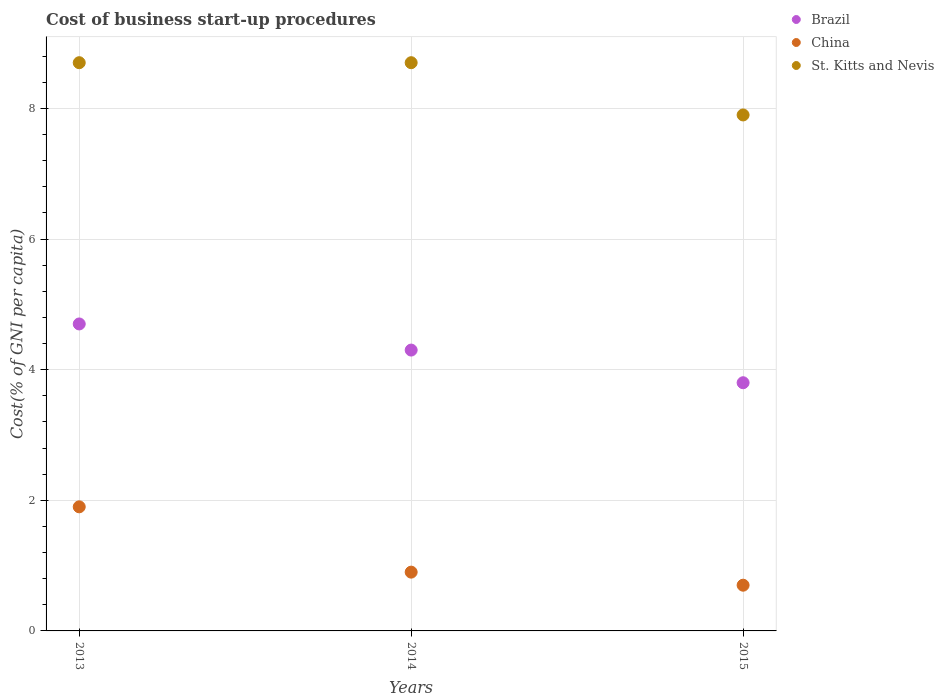Is the number of dotlines equal to the number of legend labels?
Offer a terse response. Yes. What is the cost of business start-up procedures in Brazil in 2013?
Your answer should be compact. 4.7. Across all years, what is the minimum cost of business start-up procedures in St. Kitts and Nevis?
Provide a short and direct response. 7.9. In which year was the cost of business start-up procedures in Brazil minimum?
Offer a terse response. 2015. What is the total cost of business start-up procedures in Brazil in the graph?
Provide a short and direct response. 12.8. What is the difference between the cost of business start-up procedures in China in 2015 and the cost of business start-up procedures in Brazil in 2013?
Ensure brevity in your answer.  -4. What is the average cost of business start-up procedures in Brazil per year?
Offer a terse response. 4.27. In the year 2015, what is the difference between the cost of business start-up procedures in China and cost of business start-up procedures in Brazil?
Give a very brief answer. -3.1. In how many years, is the cost of business start-up procedures in China greater than 7.6 %?
Ensure brevity in your answer.  0. What is the ratio of the cost of business start-up procedures in China in 2013 to that in 2014?
Your answer should be very brief. 2.11. Is the cost of business start-up procedures in St. Kitts and Nevis in 2013 less than that in 2014?
Provide a succinct answer. No. Is the difference between the cost of business start-up procedures in China in 2013 and 2015 greater than the difference between the cost of business start-up procedures in Brazil in 2013 and 2015?
Keep it short and to the point. Yes. What is the difference between the highest and the second highest cost of business start-up procedures in China?
Offer a very short reply. 1. What is the difference between the highest and the lowest cost of business start-up procedures in Brazil?
Your response must be concise. 0.9. In how many years, is the cost of business start-up procedures in China greater than the average cost of business start-up procedures in China taken over all years?
Provide a succinct answer. 1. Is the sum of the cost of business start-up procedures in China in 2013 and 2014 greater than the maximum cost of business start-up procedures in Brazil across all years?
Offer a terse response. No. Is the cost of business start-up procedures in Brazil strictly greater than the cost of business start-up procedures in St. Kitts and Nevis over the years?
Your answer should be very brief. No. How many dotlines are there?
Give a very brief answer. 3. How many years are there in the graph?
Keep it short and to the point. 3. What is the difference between two consecutive major ticks on the Y-axis?
Your answer should be very brief. 2. Are the values on the major ticks of Y-axis written in scientific E-notation?
Your answer should be compact. No. Does the graph contain any zero values?
Provide a succinct answer. No. Where does the legend appear in the graph?
Offer a very short reply. Top right. How many legend labels are there?
Offer a very short reply. 3. How are the legend labels stacked?
Keep it short and to the point. Vertical. What is the title of the graph?
Give a very brief answer. Cost of business start-up procedures. Does "Paraguay" appear as one of the legend labels in the graph?
Your response must be concise. No. What is the label or title of the X-axis?
Make the answer very short. Years. What is the label or title of the Y-axis?
Offer a very short reply. Cost(% of GNI per capita). What is the Cost(% of GNI per capita) in Brazil in 2013?
Ensure brevity in your answer.  4.7. What is the Cost(% of GNI per capita) of China in 2013?
Your answer should be very brief. 1.9. What is the Cost(% of GNI per capita) in St. Kitts and Nevis in 2014?
Offer a very short reply. 8.7. What is the Cost(% of GNI per capita) in China in 2015?
Make the answer very short. 0.7. What is the Cost(% of GNI per capita) of St. Kitts and Nevis in 2015?
Your answer should be compact. 7.9. Across all years, what is the maximum Cost(% of GNI per capita) in Brazil?
Your response must be concise. 4.7. Across all years, what is the minimum Cost(% of GNI per capita) in China?
Provide a short and direct response. 0.7. Across all years, what is the minimum Cost(% of GNI per capita) of St. Kitts and Nevis?
Ensure brevity in your answer.  7.9. What is the total Cost(% of GNI per capita) in China in the graph?
Ensure brevity in your answer.  3.5. What is the total Cost(% of GNI per capita) in St. Kitts and Nevis in the graph?
Offer a very short reply. 25.3. What is the difference between the Cost(% of GNI per capita) in Brazil in 2013 and that in 2015?
Keep it short and to the point. 0.9. What is the difference between the Cost(% of GNI per capita) in China in 2013 and that in 2015?
Your answer should be very brief. 1.2. What is the difference between the Cost(% of GNI per capita) of Brazil in 2014 and that in 2015?
Provide a succinct answer. 0.5. What is the difference between the Cost(% of GNI per capita) in Brazil in 2013 and the Cost(% of GNI per capita) in St. Kitts and Nevis in 2014?
Ensure brevity in your answer.  -4. What is the difference between the Cost(% of GNI per capita) in China in 2013 and the Cost(% of GNI per capita) in St. Kitts and Nevis in 2014?
Give a very brief answer. -6.8. What is the difference between the Cost(% of GNI per capita) in Brazil in 2013 and the Cost(% of GNI per capita) in China in 2015?
Your answer should be very brief. 4. What is the difference between the Cost(% of GNI per capita) of China in 2013 and the Cost(% of GNI per capita) of St. Kitts and Nevis in 2015?
Offer a terse response. -6. What is the difference between the Cost(% of GNI per capita) of Brazil in 2014 and the Cost(% of GNI per capita) of China in 2015?
Make the answer very short. 3.6. What is the difference between the Cost(% of GNI per capita) of Brazil in 2014 and the Cost(% of GNI per capita) of St. Kitts and Nevis in 2015?
Provide a short and direct response. -3.6. What is the difference between the Cost(% of GNI per capita) of China in 2014 and the Cost(% of GNI per capita) of St. Kitts and Nevis in 2015?
Ensure brevity in your answer.  -7. What is the average Cost(% of GNI per capita) of Brazil per year?
Keep it short and to the point. 4.27. What is the average Cost(% of GNI per capita) of St. Kitts and Nevis per year?
Offer a terse response. 8.43. In the year 2013, what is the difference between the Cost(% of GNI per capita) of Brazil and Cost(% of GNI per capita) of China?
Keep it short and to the point. 2.8. In the year 2013, what is the difference between the Cost(% of GNI per capita) in China and Cost(% of GNI per capita) in St. Kitts and Nevis?
Your answer should be very brief. -6.8. In the year 2015, what is the difference between the Cost(% of GNI per capita) in Brazil and Cost(% of GNI per capita) in St. Kitts and Nevis?
Your answer should be compact. -4.1. What is the ratio of the Cost(% of GNI per capita) in Brazil in 2013 to that in 2014?
Provide a short and direct response. 1.09. What is the ratio of the Cost(% of GNI per capita) in China in 2013 to that in 2014?
Provide a succinct answer. 2.11. What is the ratio of the Cost(% of GNI per capita) of Brazil in 2013 to that in 2015?
Ensure brevity in your answer.  1.24. What is the ratio of the Cost(% of GNI per capita) in China in 2013 to that in 2015?
Your response must be concise. 2.71. What is the ratio of the Cost(% of GNI per capita) of St. Kitts and Nevis in 2013 to that in 2015?
Provide a succinct answer. 1.1. What is the ratio of the Cost(% of GNI per capita) of Brazil in 2014 to that in 2015?
Offer a terse response. 1.13. What is the ratio of the Cost(% of GNI per capita) in China in 2014 to that in 2015?
Keep it short and to the point. 1.29. What is the ratio of the Cost(% of GNI per capita) in St. Kitts and Nevis in 2014 to that in 2015?
Make the answer very short. 1.1. What is the difference between the highest and the second highest Cost(% of GNI per capita) in Brazil?
Make the answer very short. 0.4. What is the difference between the highest and the second highest Cost(% of GNI per capita) in St. Kitts and Nevis?
Ensure brevity in your answer.  0. What is the difference between the highest and the lowest Cost(% of GNI per capita) in Brazil?
Ensure brevity in your answer.  0.9. What is the difference between the highest and the lowest Cost(% of GNI per capita) in St. Kitts and Nevis?
Offer a terse response. 0.8. 